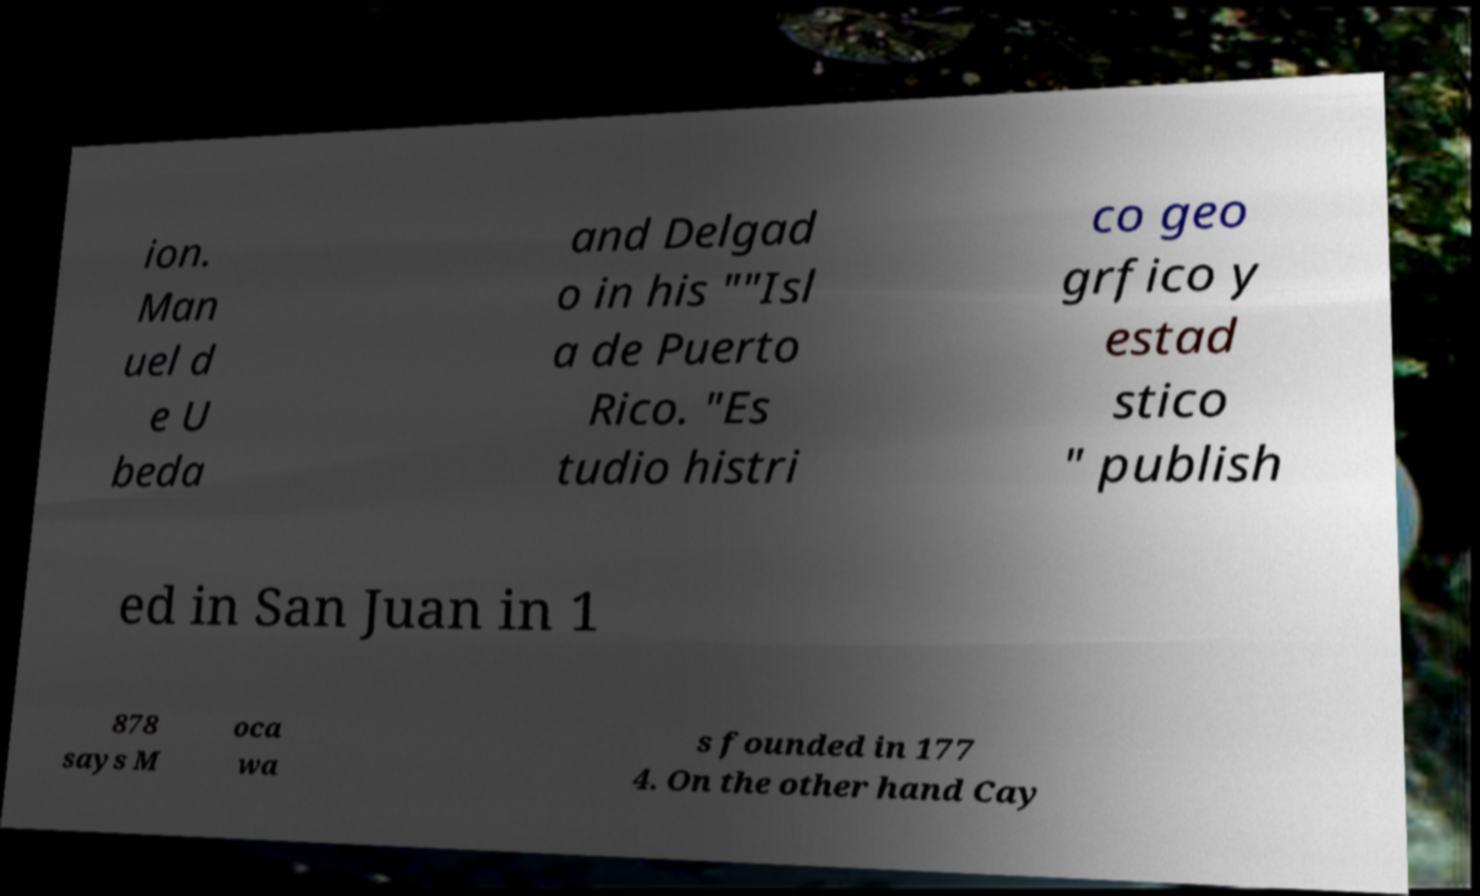There's text embedded in this image that I need extracted. Can you transcribe it verbatim? ion. Man uel d e U beda and Delgad o in his ""Isl a de Puerto Rico. "Es tudio histri co geo grfico y estad stico " publish ed in San Juan in 1 878 says M oca wa s founded in 177 4. On the other hand Cay 